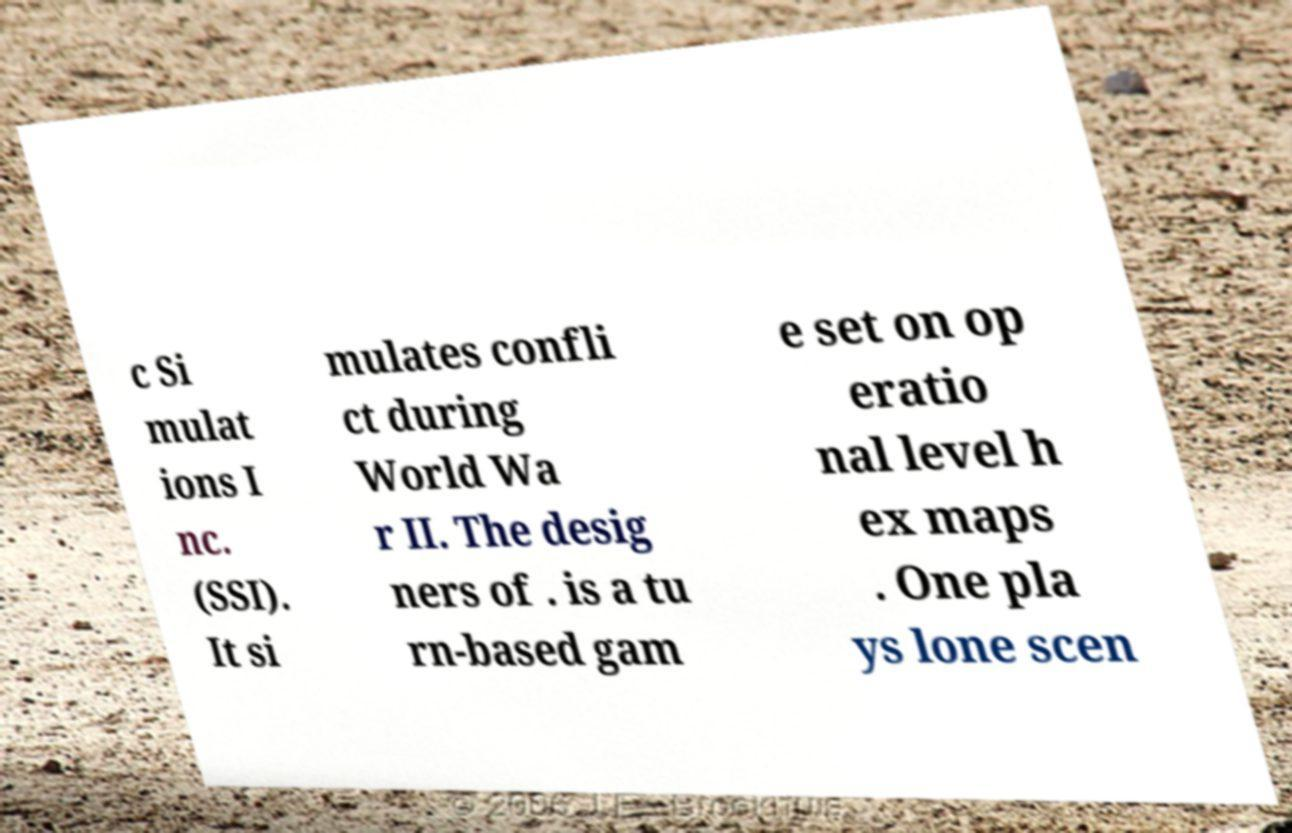Please identify and transcribe the text found in this image. c Si mulat ions I nc. (SSI). It si mulates confli ct during World Wa r II. The desig ners of . is a tu rn-based gam e set on op eratio nal level h ex maps . One pla ys lone scen 